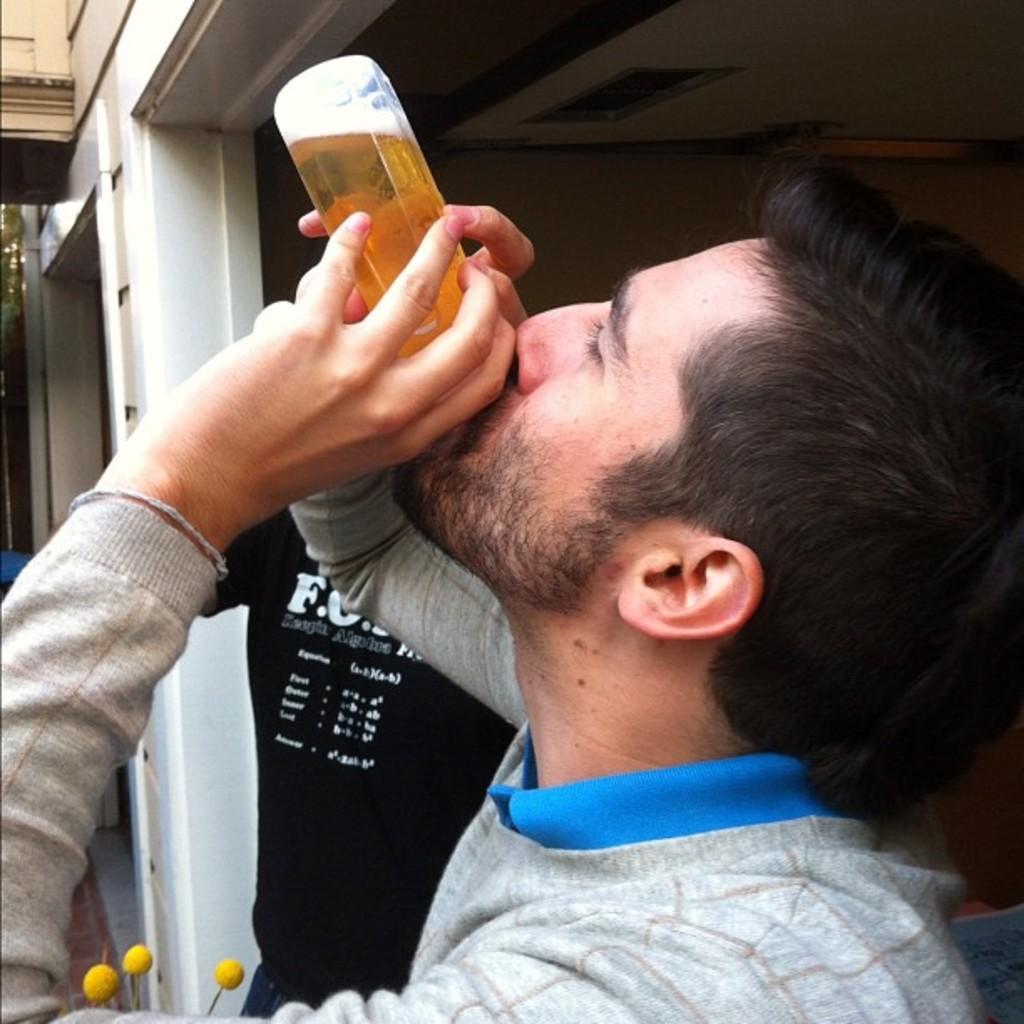Who is present in the image? There is a man in the image. What is the man wearing? The man is wearing a blue t-shirt and a grey sweatshirt. What is the man holding in the image? The man is holding a bottle. What is the man doing with the bottle? The man is drinking from the bottle. What type of dog can be seen playing with the man in the image? There is no dog present in the image; it only features a man holding and drinking from a bottle. 